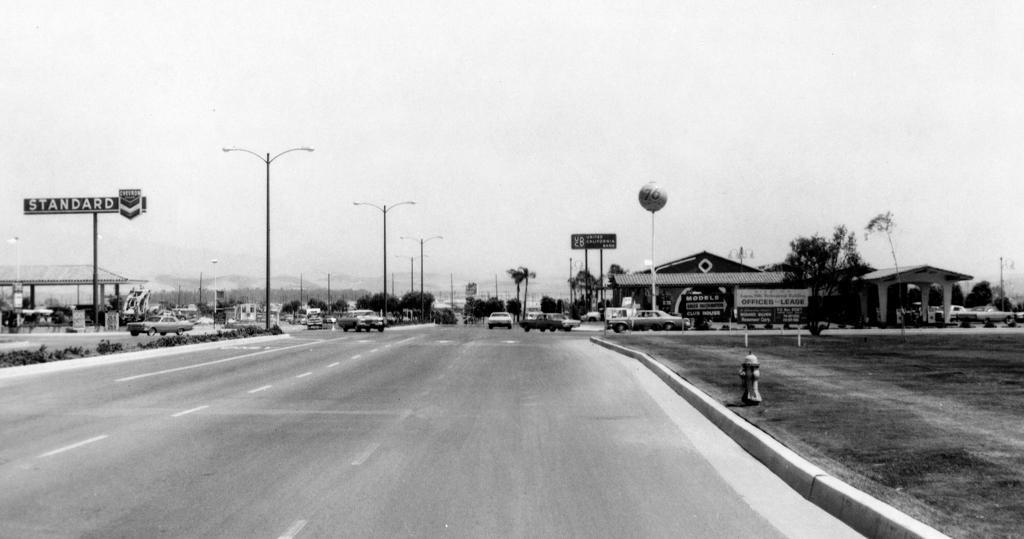Describe this image in one or two sentences. In the middle of the image there are some vehicles on the road. Behind the vehicles there are some poles, trees, hoardings and buildings. At the top of the image there is sky. At the bottom of the image there is grass. 